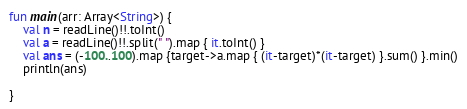Convert code to text. <code><loc_0><loc_0><loc_500><loc_500><_Kotlin_>fun main(arr: Array<String>) {
    val n = readLine()!!.toInt()
    val a = readLine()!!.split(" ").map { it.toInt() }
    val ans = (-100..100).map {target->a.map { (it-target)*(it-target) }.sum() }.min()
    println(ans)

}

</code> 